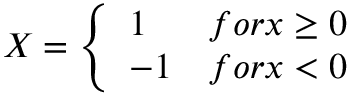Convert formula to latex. <formula><loc_0><loc_0><loc_500><loc_500>X = \left \{ \begin{array} { l l } { 1 } & { f o r x \geq 0 } \\ { - 1 } & { f o r x < 0 } \end{array}</formula> 